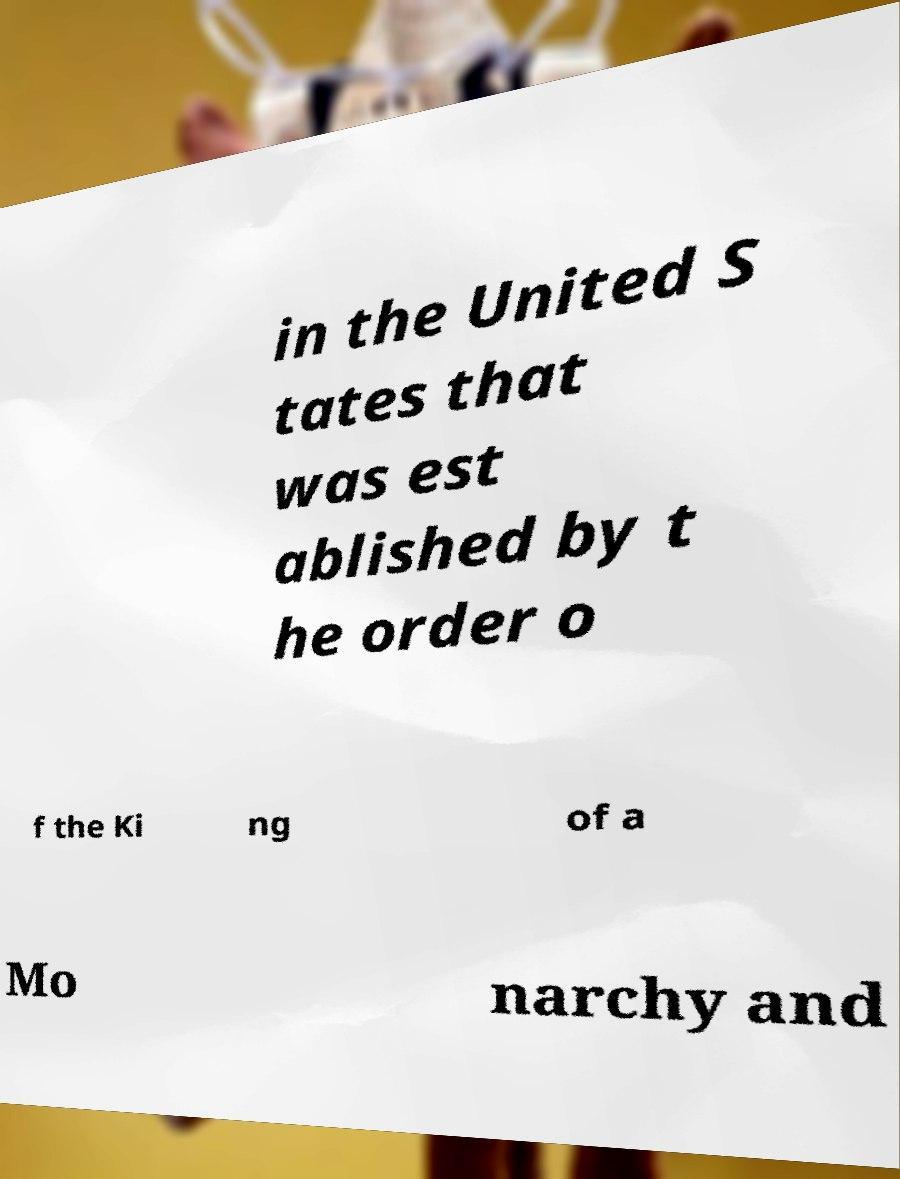For documentation purposes, I need the text within this image transcribed. Could you provide that? in the United S tates that was est ablished by t he order o f the Ki ng of a Mo narchy and 